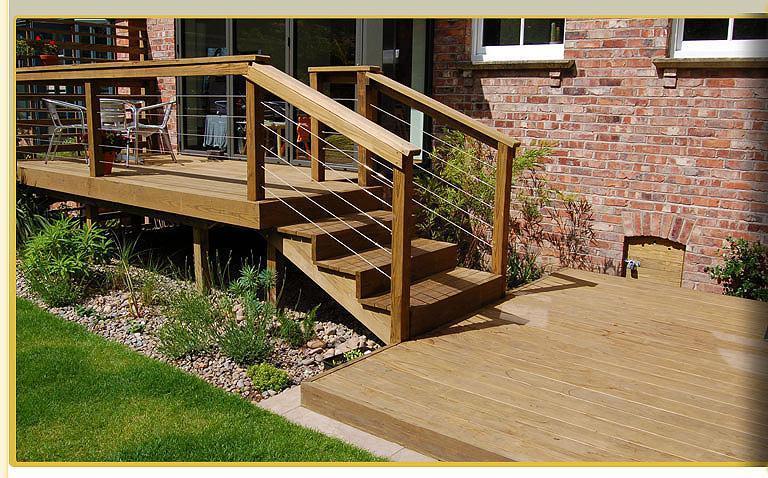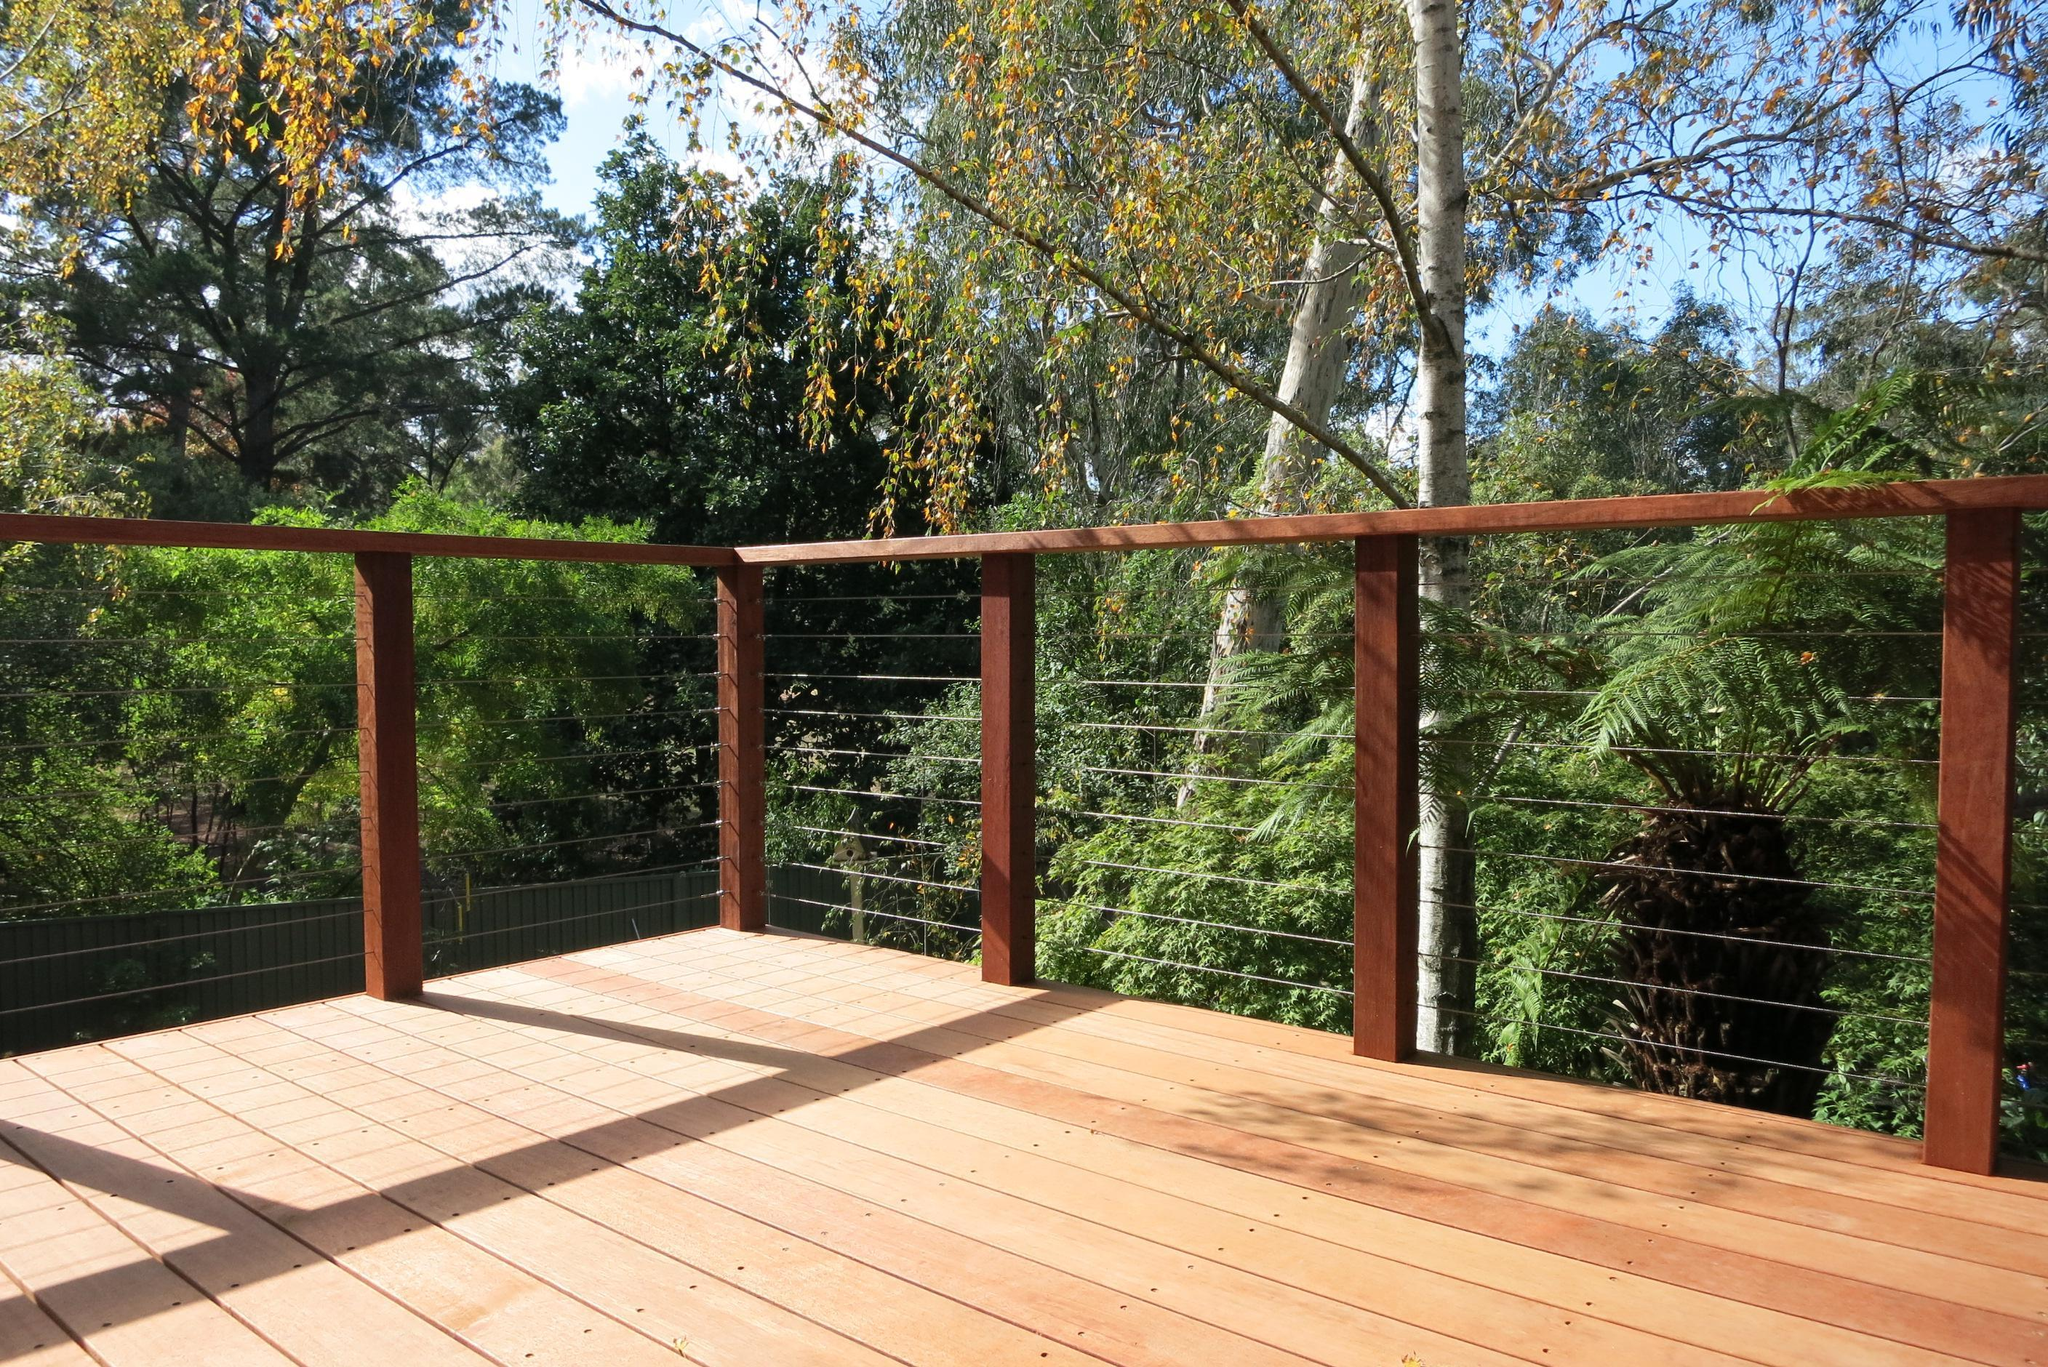The first image is the image on the left, the second image is the image on the right. Analyze the images presented: Is the assertion "The left image shows the corner of a deck with a silver-colored pipe-shaped handrail and thin horizontal metal rods beween upright metal posts." valid? Answer yes or no. No. 